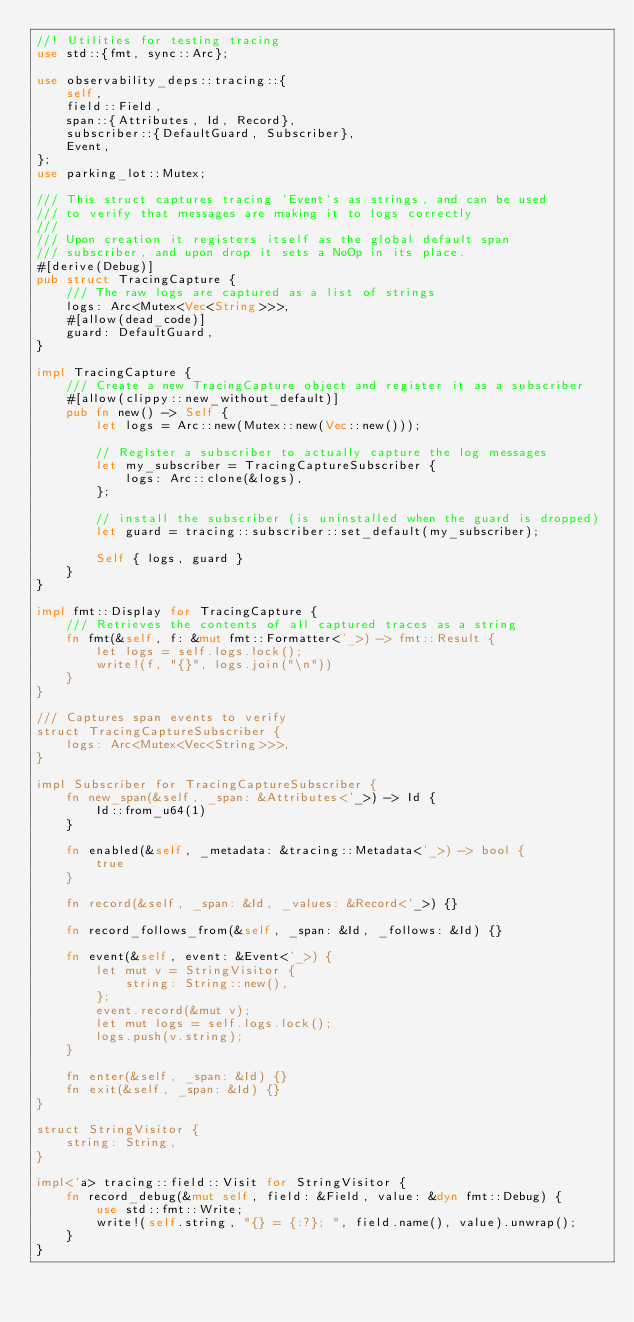Convert code to text. <code><loc_0><loc_0><loc_500><loc_500><_Rust_>//! Utilities for testing tracing
use std::{fmt, sync::Arc};

use observability_deps::tracing::{
    self,
    field::Field,
    span::{Attributes, Id, Record},
    subscriber::{DefaultGuard, Subscriber},
    Event,
};
use parking_lot::Mutex;

/// This struct captures tracing `Event`s as strings, and can be used
/// to verify that messages are making it to logs correctly
///
/// Upon creation it registers itself as the global default span
/// subscriber, and upon drop it sets a NoOp in its place.
#[derive(Debug)]
pub struct TracingCapture {
    /// The raw logs are captured as a list of strings
    logs: Arc<Mutex<Vec<String>>>,
    #[allow(dead_code)]
    guard: DefaultGuard,
}

impl TracingCapture {
    /// Create a new TracingCapture object and register it as a subscriber
    #[allow(clippy::new_without_default)]
    pub fn new() -> Self {
        let logs = Arc::new(Mutex::new(Vec::new()));

        // Register a subscriber to actually capture the log messages
        let my_subscriber = TracingCaptureSubscriber {
            logs: Arc::clone(&logs),
        };

        // install the subscriber (is uninstalled when the guard is dropped)
        let guard = tracing::subscriber::set_default(my_subscriber);

        Self { logs, guard }
    }
}

impl fmt::Display for TracingCapture {
    /// Retrieves the contents of all captured traces as a string
    fn fmt(&self, f: &mut fmt::Formatter<'_>) -> fmt::Result {
        let logs = self.logs.lock();
        write!(f, "{}", logs.join("\n"))
    }
}

/// Captures span events to verify
struct TracingCaptureSubscriber {
    logs: Arc<Mutex<Vec<String>>>,
}

impl Subscriber for TracingCaptureSubscriber {
    fn new_span(&self, _span: &Attributes<'_>) -> Id {
        Id::from_u64(1)
    }

    fn enabled(&self, _metadata: &tracing::Metadata<'_>) -> bool {
        true
    }

    fn record(&self, _span: &Id, _values: &Record<'_>) {}

    fn record_follows_from(&self, _span: &Id, _follows: &Id) {}

    fn event(&self, event: &Event<'_>) {
        let mut v = StringVisitor {
            string: String::new(),
        };
        event.record(&mut v);
        let mut logs = self.logs.lock();
        logs.push(v.string);
    }

    fn enter(&self, _span: &Id) {}
    fn exit(&self, _span: &Id) {}
}

struct StringVisitor {
    string: String,
}

impl<'a> tracing::field::Visit for StringVisitor {
    fn record_debug(&mut self, field: &Field, value: &dyn fmt::Debug) {
        use std::fmt::Write;
        write!(self.string, "{} = {:?}; ", field.name(), value).unwrap();
    }
}
</code> 